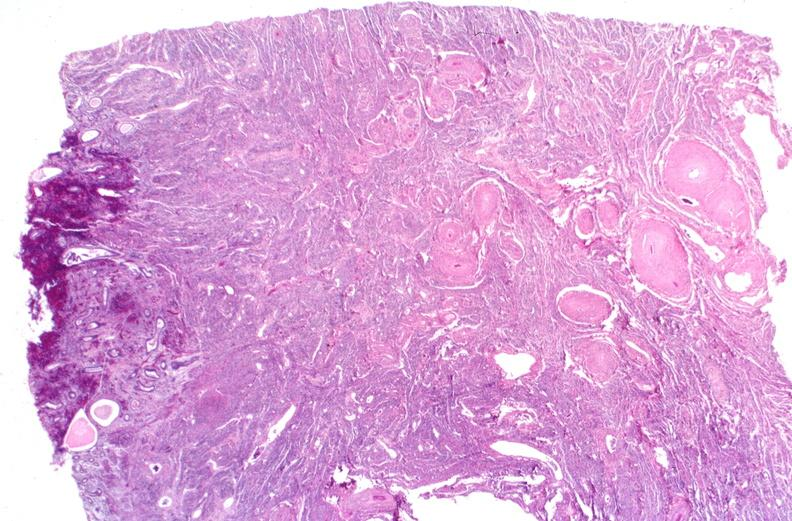does this image show kidney, polyarteritis nodosa?
Answer the question using a single word or phrase. Yes 